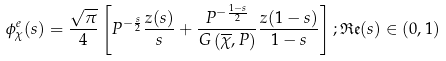Convert formula to latex. <formula><loc_0><loc_0><loc_500><loc_500>\phi _ { \chi } ^ { e } ( s ) = \frac { \sqrt { \pi } } { 4 } \left [ P ^ { - \frac { s } { 2 } } \frac { z ( s ) } { s } + \frac { P ^ { - \frac { 1 - s } { 2 } } } { G \left ( \overline { \chi } , P \right ) } \frac { z ( 1 - s ) } { 1 - s } \right ] ; \mathfrak { R e } ( s ) \in ( 0 , 1 )</formula> 